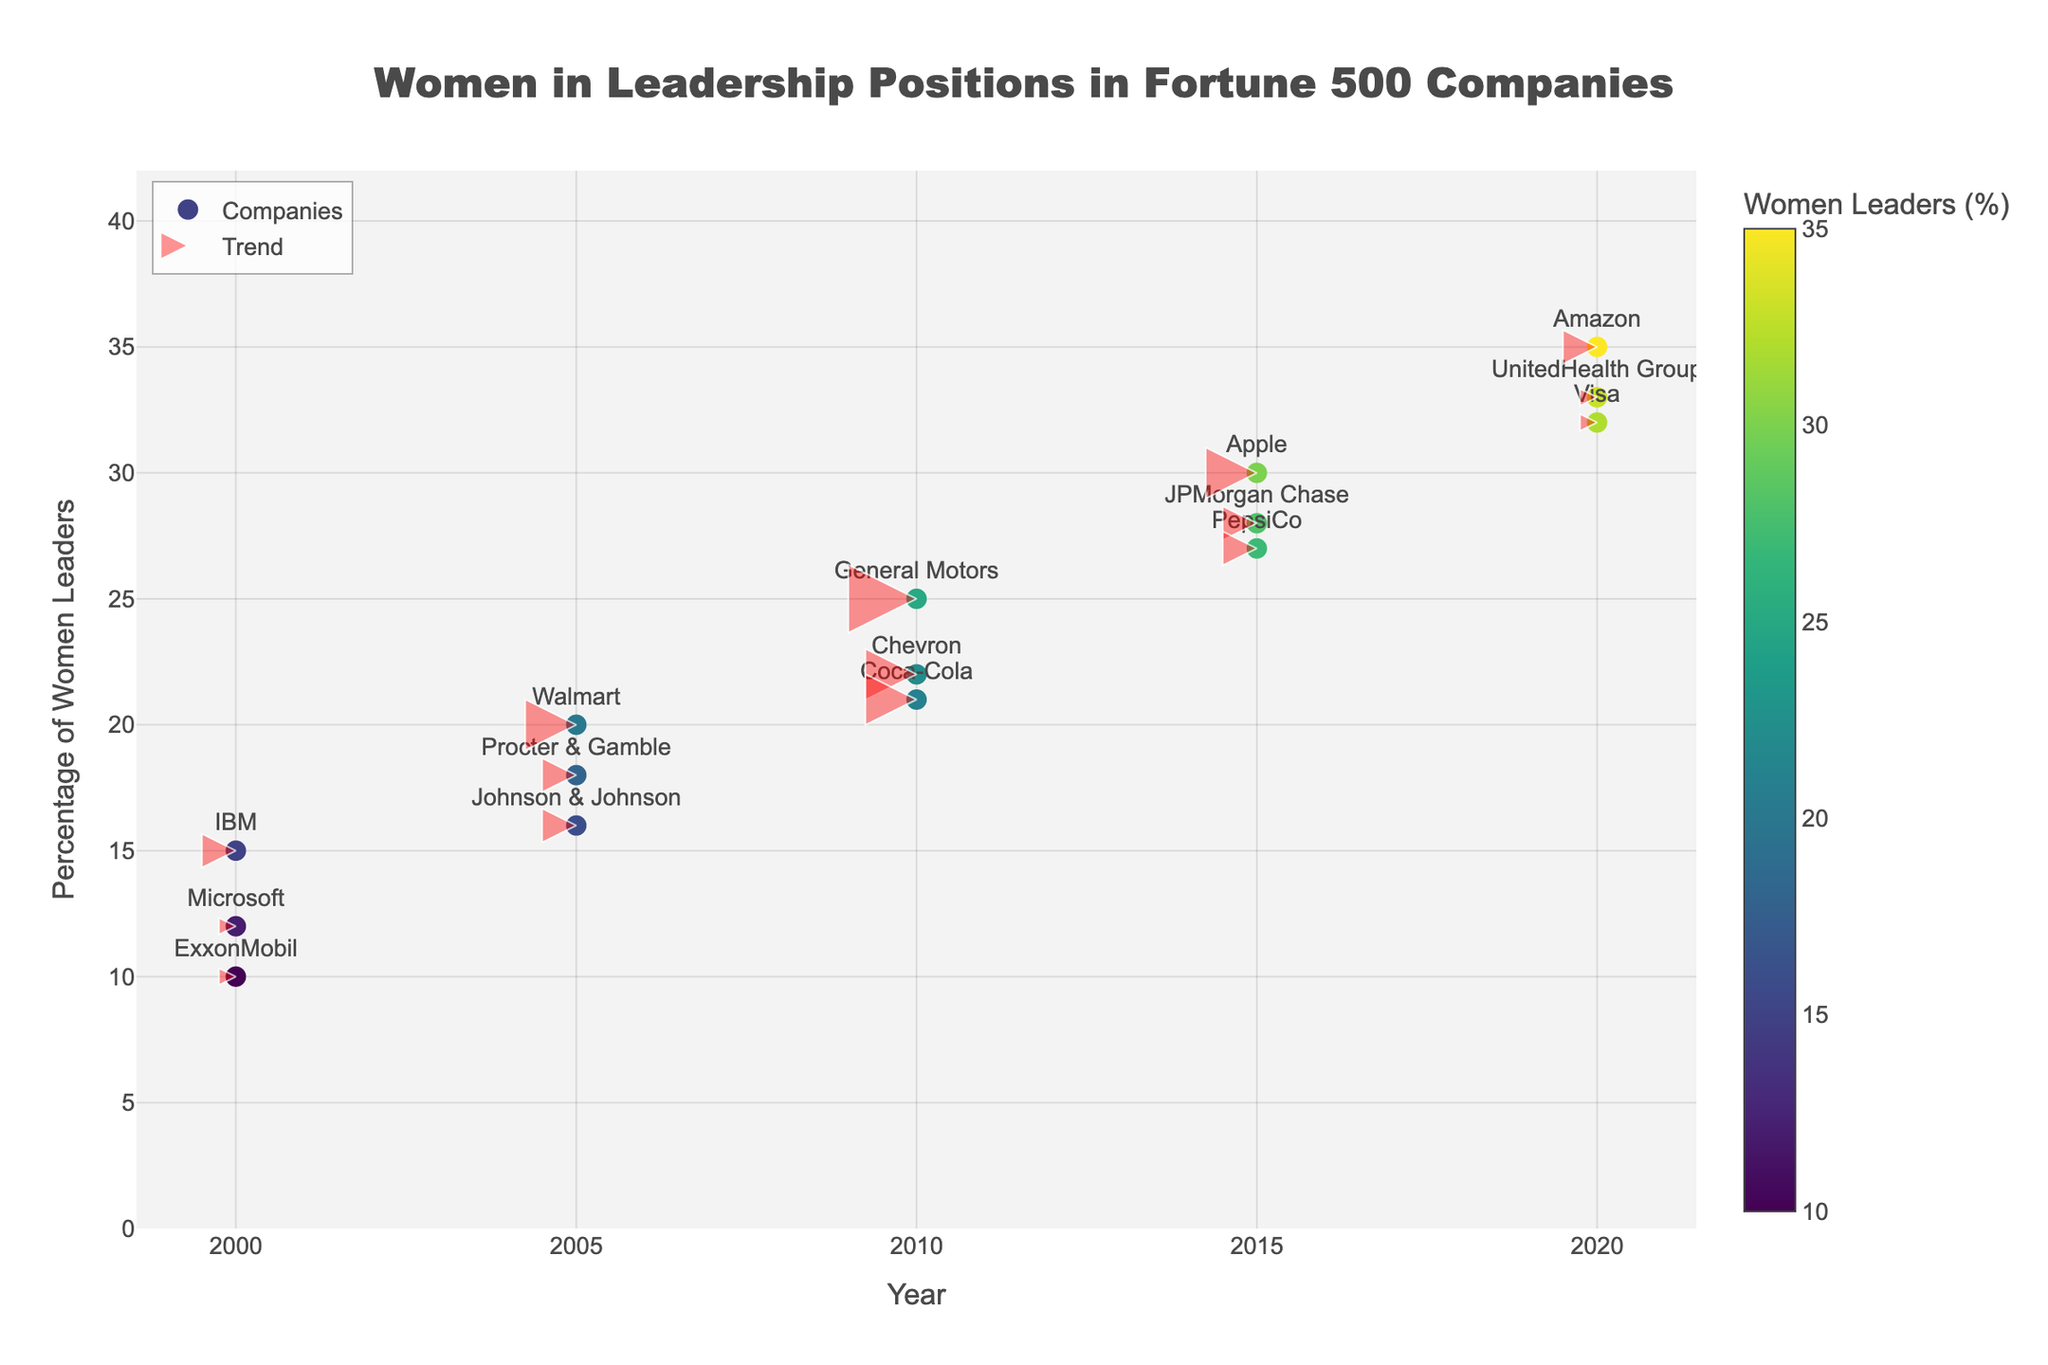What is the title of the plot? The title is prominently displayed at the top center of the plot.
Answer: Women in Leadership Positions in Fortune 500 Companies What is the average percentage of women leaders in 2020 for the companies listed? First, extract the percentages for all the companies in 2020 (35, 33, 32). Calculate their average: (35 + 33 + 32) / 3 = 33.3%.
Answer: 33.3% How many arrows are shown in the plot? Count the number of arrows represented as markers with upward-pointing arrows across the years. There are 15 arrows corresponding to the 15 data points.
Answer: 15 Which company had the lowest percentage of women leaders in 2000, and what was that percentage? Look for the smallest value in the year 2000. ExxonMobil had the lowest percentage with 10%.
Answer: ExxonMobil, 10% Did any company's percentage of women leaders decrease over time according to the plot? Observe the direction of all arrows. Since all arrows are pointing upwards, no company showed a decrease in the percentage of women leaders over the years.
Answer: No Which company showed the most significant increase in the percentage of women leaders between 2000 and 2020? Compare the trend magnitudes for each company between 2000 and 2020. The highest value is 22% (from 10% to 33%) for UnitedHealth Group.
Answer: UnitedHealth Group How does the trend magnitude for IBM between 2000 and 2020 compare to that of Amazon? IBM's trend magnitude is 2 (2000-2020), and Amazon's is 2 (2000-2020). They have the same trend magnitude.
Answer: Same What percentage range do the y-axis values span? Look at the y-axis minimum and maximum values. The range spans from 0% to roughly 40%.
Answer: 0% to 40% Among IBM, Walmart, and General Motors, which had the highest percentage of women leaders in 2010? Extract the percentage values for IBM (2010), Walmart (2010), and General Motors (2010). General Motors had the highest with 25%.
Answer: General Motors What general trend is observed for the percentage of women leaders in Fortune 500 companies from 2000 to 2020? All arrows point upward, indicating an increase in the percentage of women leaders over the years.
Answer: Increasing trend 